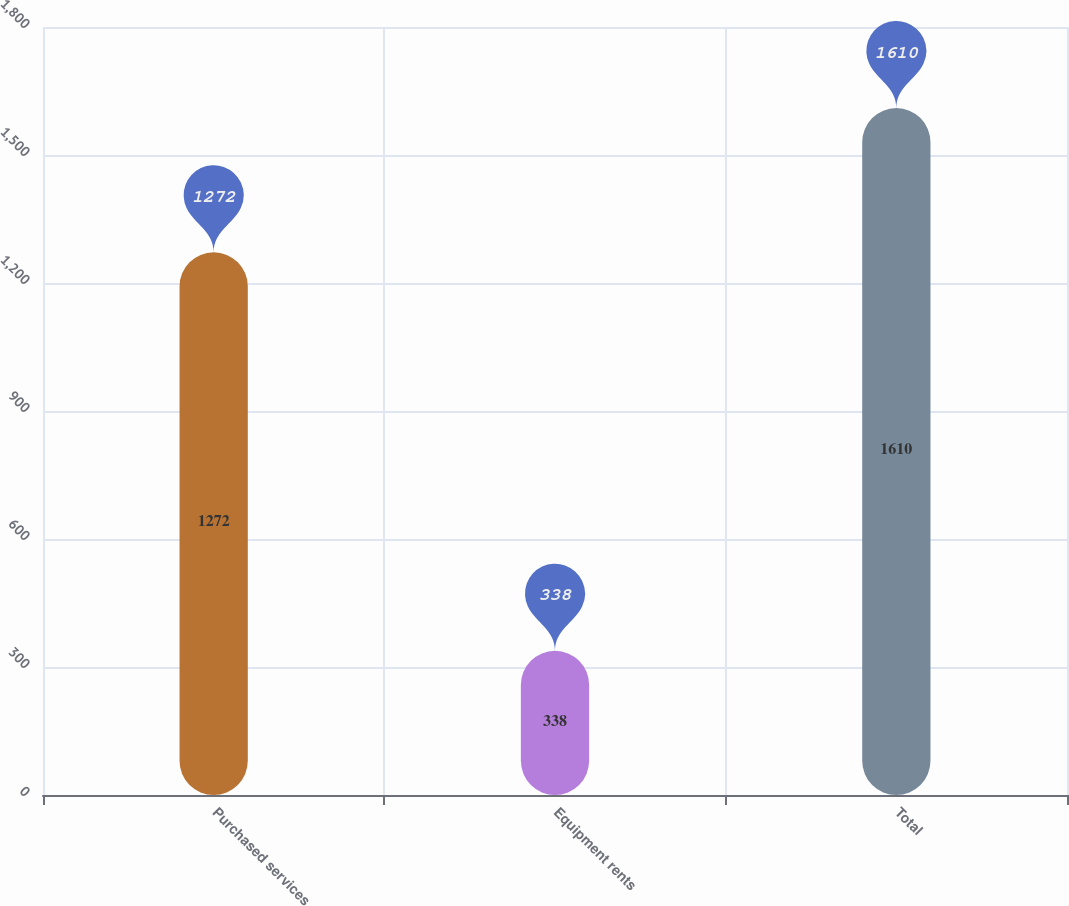<chart> <loc_0><loc_0><loc_500><loc_500><bar_chart><fcel>Purchased services<fcel>Equipment rents<fcel>Total<nl><fcel>1272<fcel>338<fcel>1610<nl></chart> 